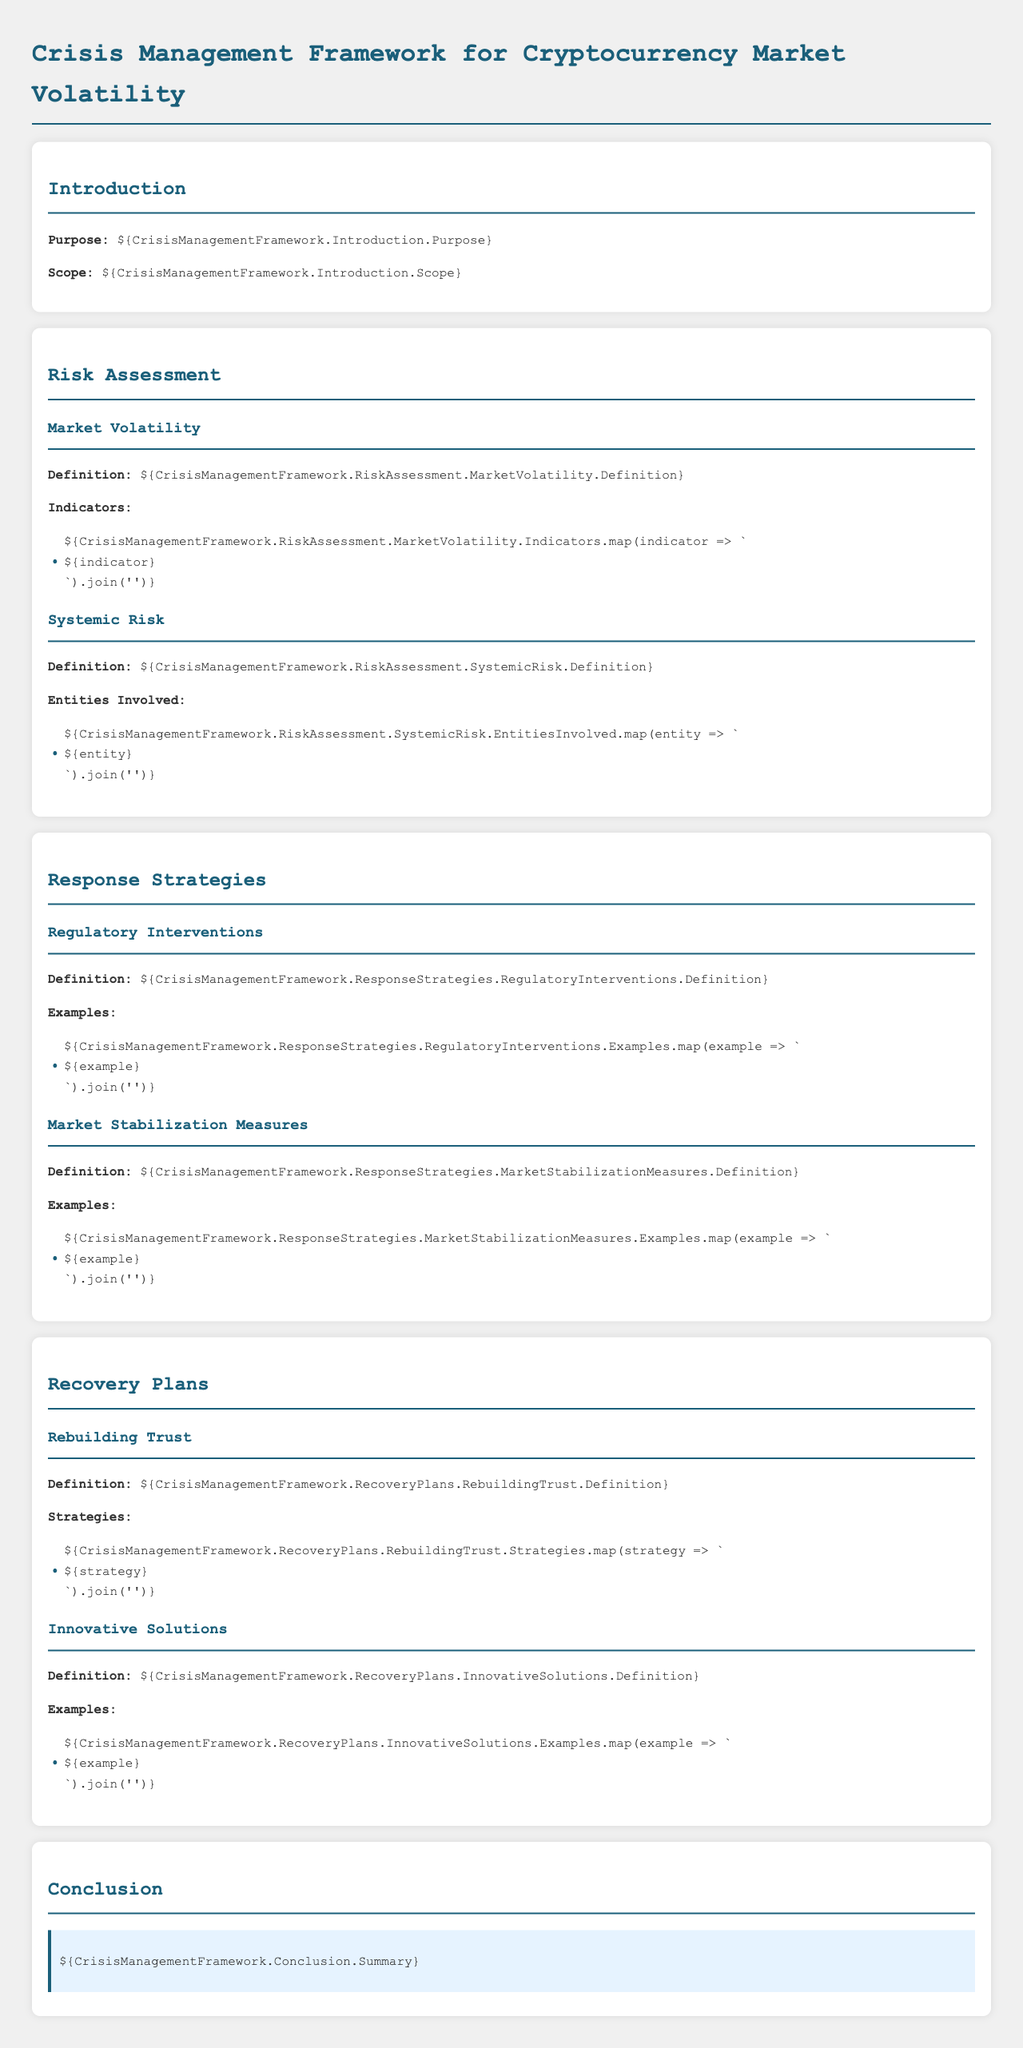What is the purpose of the framework? The purpose is outlined in the introduction section of the document as the main objective of the crisis management framework.
Answer: Addressing financial instability due to cryptocurrency volatility What are the indicators of market volatility? The indicators are listed in the market volatility section under risk assessment.
Answer: Various indicators such as price fluctuations and trading volumes Who are the entities involved in systemic risk? The entities are enumerated in the systemic risk section and reflect the key actors in the financial ecosystem.
Answer: Financial institutions, investors, and regulatory bodies What are examples of regulatory interventions? Examples are provided in the regulatory interventions section under response strategies.
Answer: Licensing requirements and disclosure mandates What is the definition of rebuilding trust? The definition is found in the rebuilding trust section and highlights the importance of trust in recovery.
Answer: Restoring confidence among market participants What strategies are mentioned for rebuilding trust? The strategies are highlighted under the rebuilding trust section and detail methods for fostering confidence.
Answer: Transparency and effective communication What type of recovery solutions are discussed? The document outlines innovative solutions in response to market instability under the recovery plans section.
Answer: Technology-driven financial products What is the main theme of the conclusion? The conclusion summarizes the overall essence of the document, emphasizing the need for proactive measures.
Answer: Importance of a comprehensive crisis management framework 